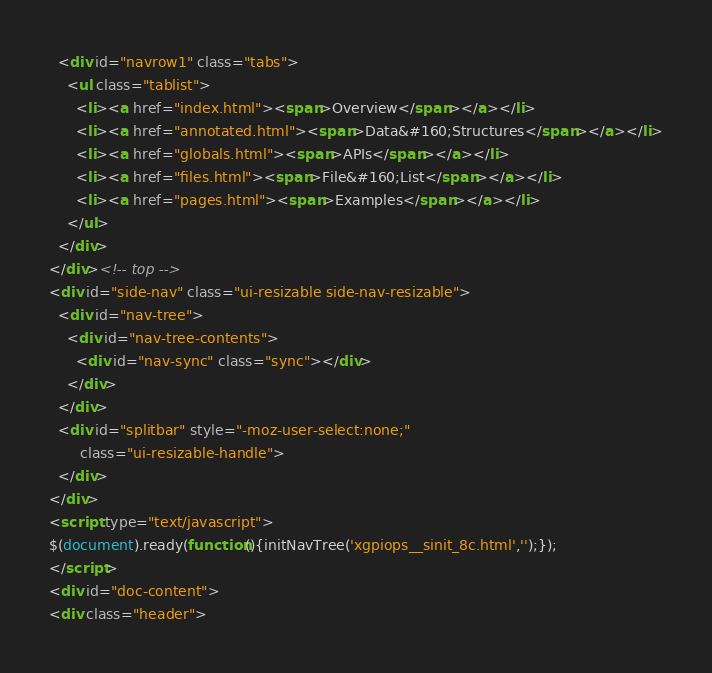Convert code to text. <code><loc_0><loc_0><loc_500><loc_500><_HTML_>  <div id="navrow1" class="tabs">
    <ul class="tablist">
      <li><a href="index.html"><span>Overview</span></a></li>
      <li><a href="annotated.html"><span>Data&#160;Structures</span></a></li>
      <li><a href="globals.html"><span>APIs</span></a></li>
      <li><a href="files.html"><span>File&#160;List</span></a></li>
      <li><a href="pages.html"><span>Examples</span></a></li>
    </ul>
  </div>
</div><!-- top -->
<div id="side-nav" class="ui-resizable side-nav-resizable">
  <div id="nav-tree">
    <div id="nav-tree-contents">
      <div id="nav-sync" class="sync"></div>
    </div>
  </div>
  <div id="splitbar" style="-moz-user-select:none;" 
       class="ui-resizable-handle">
  </div>
</div>
<script type="text/javascript">
$(document).ready(function(){initNavTree('xgpiops__sinit_8c.html','');});
</script>
<div id="doc-content">
<div class="header"></code> 